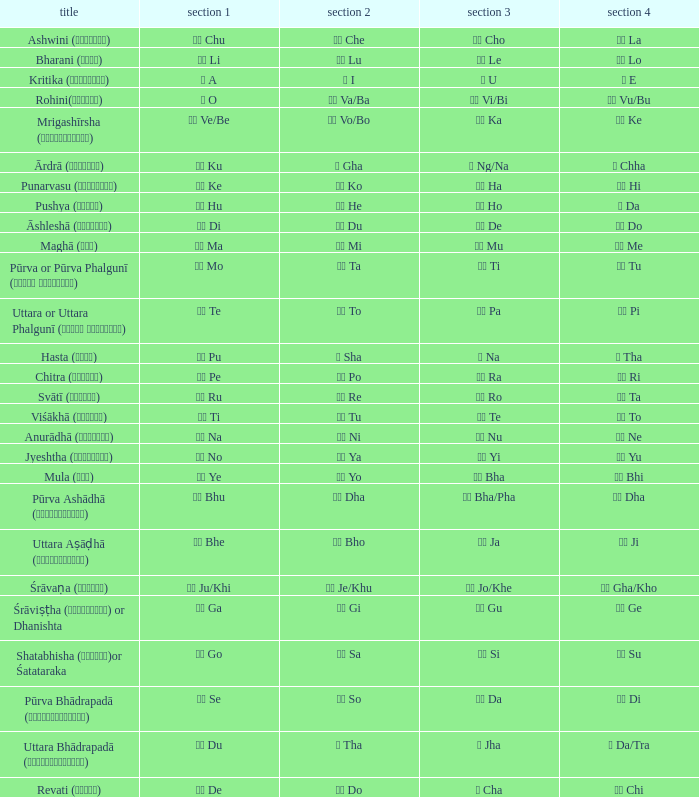Which pada 4 has a pada 2 of थ tha? ञ Da/Tra. 